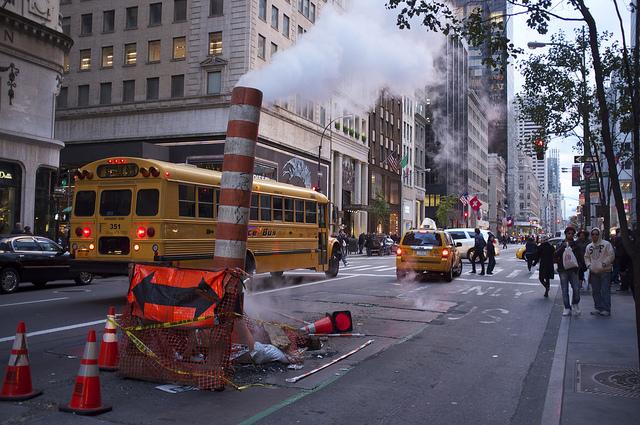Is this in Paris?
Be succinct. No. Is the bus full of tourists?
Keep it brief. No. Do the trees have leaves on them?
Write a very short answer. Yes. What are the yellow cars called?
Answer briefly. Taxi. How are these buses different than other buses?
Write a very short answer. School bus. What color is the bus in this image?
Be succinct. Yellow. Is traffic visible?
Concise answer only. Yes. What is the white stuff falling from the sky?
Write a very short answer. Smoke. Are most of these people students?
Concise answer only. No. Is this a rural area?
Concise answer only. No. What does the construction sign say?
Quick response, please. Move. Do these vehicle consume gasoline?
Short answer required. Yes. What kind of bus is in the picture?
Be succinct. School. Are the sidewalks crowded?
Keep it brief. Yes. What type of vehicle is in the picture?
Quick response, please. Bus. How many striped cones are there?
Be succinct. 4. Can the biker go faster than the bus?
Be succinct. Yes. Is this a contemporary scene?
Answer briefly. Yes. What color is the stop light?
Concise answer only. Red. Is this in America?
Be succinct. Yes. What color is the bus?
Concise answer only. Yellow. How many cars are in the picture?
Quick response, please. 5. 